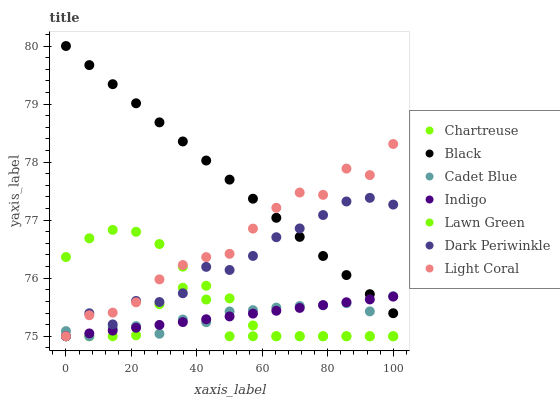Does Chartreuse have the minimum area under the curve?
Answer yes or no. Yes. Does Black have the maximum area under the curve?
Answer yes or no. Yes. Does Cadet Blue have the minimum area under the curve?
Answer yes or no. No. Does Cadet Blue have the maximum area under the curve?
Answer yes or no. No. Is Black the smoothest?
Answer yes or no. Yes. Is Dark Periwinkle the roughest?
Answer yes or no. Yes. Is Cadet Blue the smoothest?
Answer yes or no. No. Is Cadet Blue the roughest?
Answer yes or no. No. Does Lawn Green have the lowest value?
Answer yes or no. Yes. Does Black have the lowest value?
Answer yes or no. No. Does Black have the highest value?
Answer yes or no. Yes. Does Cadet Blue have the highest value?
Answer yes or no. No. Is Lawn Green less than Black?
Answer yes or no. Yes. Is Black greater than Lawn Green?
Answer yes or no. Yes. Does Lawn Green intersect Indigo?
Answer yes or no. Yes. Is Lawn Green less than Indigo?
Answer yes or no. No. Is Lawn Green greater than Indigo?
Answer yes or no. No. Does Lawn Green intersect Black?
Answer yes or no. No. 